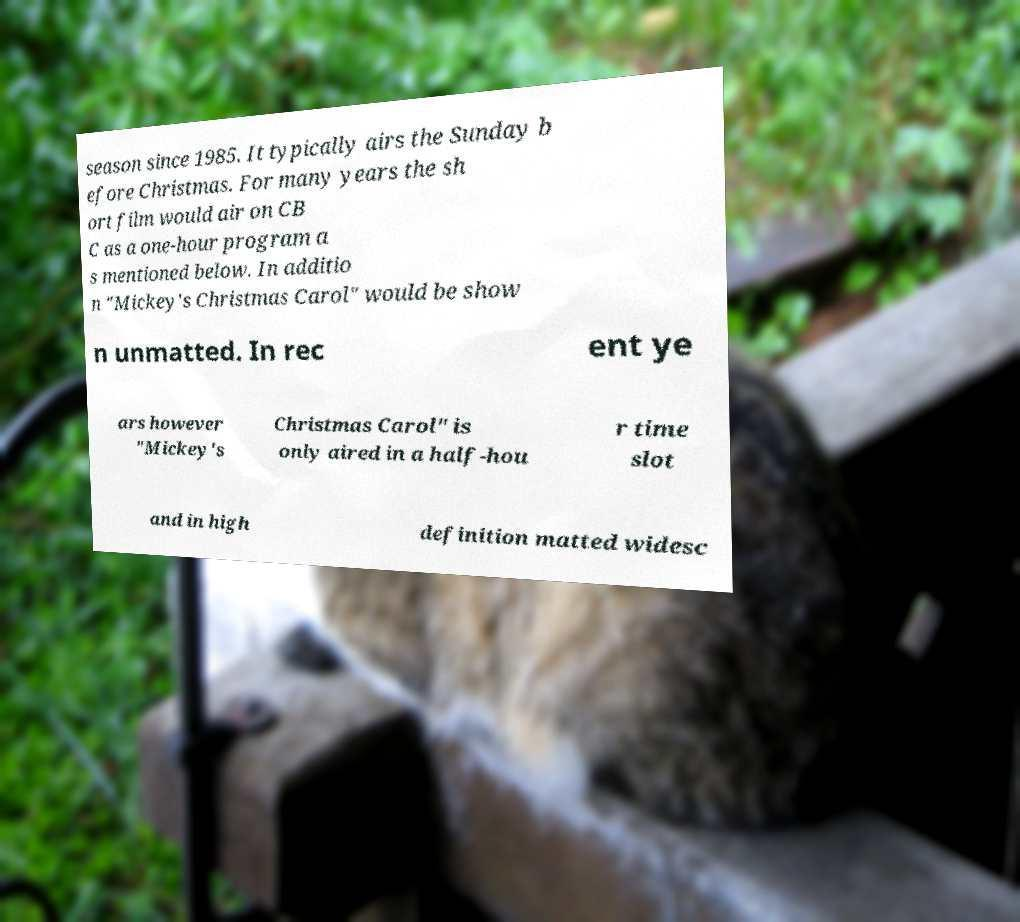Could you assist in decoding the text presented in this image and type it out clearly? season since 1985. It typically airs the Sunday b efore Christmas. For many years the sh ort film would air on CB C as a one-hour program a s mentioned below. In additio n "Mickey's Christmas Carol" would be show n unmatted. In rec ent ye ars however "Mickey's Christmas Carol" is only aired in a half-hou r time slot and in high definition matted widesc 